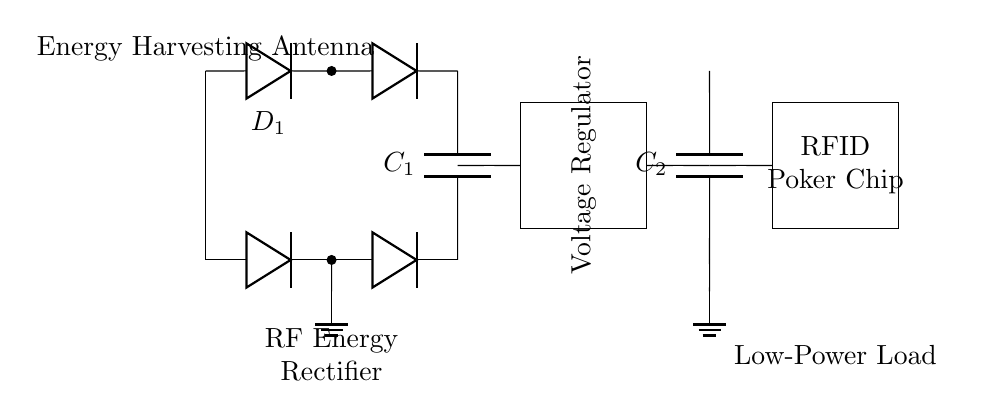What is the main function of the energy harvesting antenna? The energy harvesting antenna collects RF energy from the environment, converting it into electrical energy for the circuit.
Answer: Collecting RF energy What type of components are D1 and D2? D1 and D2 are diodes used in the rectification process to convert alternating current to direct current.
Answer: Diodes Which component is responsible for smoothing the output voltage? The smoothing capacitor, labeled C1, is responsible for reducing voltage fluctuations and providing a stable output voltage to the load.
Answer: C1 What does the voltage regulator do in this circuit? The voltage regulator ensures that the output voltage remains constant at a desired level, despite variations in input voltage or load conditions.
Answer: Maintain constant voltage Why are there two ground connections in the circuit? The ground connections provide a common reference point for the circuit and ensure that both the rectifier and load circuits are electrically grounded for safety and stability.
Answer: For reference and safety What type of load is powered by this circuit? The circuit powers a low-power load specifically designed for RFID poker chips, which operate on minimal energy.
Answer: RFID poker chip How does the output capacitor function in this circuit? The output capacitor, labeled C2, helps to filter the output signal further and stabilize the voltage supply to the load by storing and releasing energy as needed.
Answer: Filtering and stabilizing voltage 